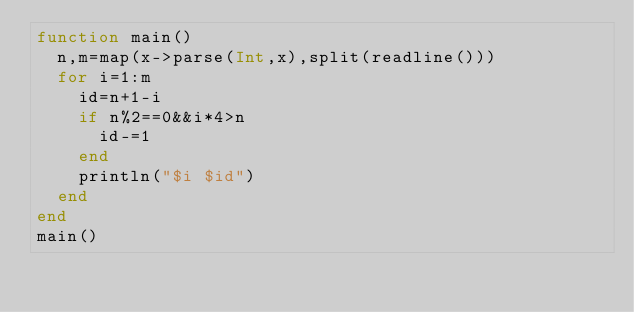Convert code to text. <code><loc_0><loc_0><loc_500><loc_500><_Julia_>function main()
  n,m=map(x->parse(Int,x),split(readline()))
  for i=1:m
    id=n+1-i
    if n%2==0&&i*4>n
      id-=1
    end
    println("$i $id")
  end
end
main()
</code> 